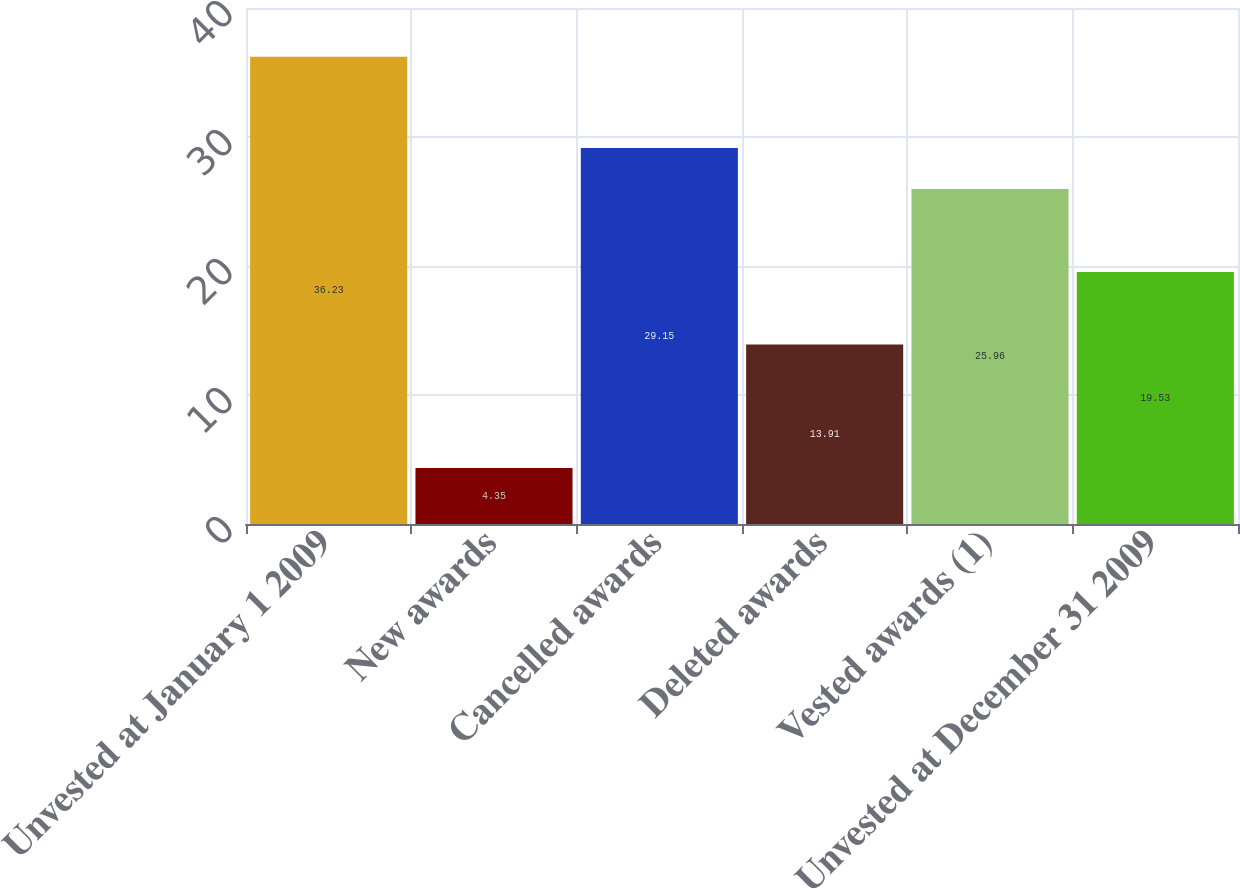<chart> <loc_0><loc_0><loc_500><loc_500><bar_chart><fcel>Unvested at January 1 2009<fcel>New awards<fcel>Cancelled awards<fcel>Deleted awards<fcel>Vested awards (1)<fcel>Unvested at December 31 2009<nl><fcel>36.23<fcel>4.35<fcel>29.15<fcel>13.91<fcel>25.96<fcel>19.53<nl></chart> 